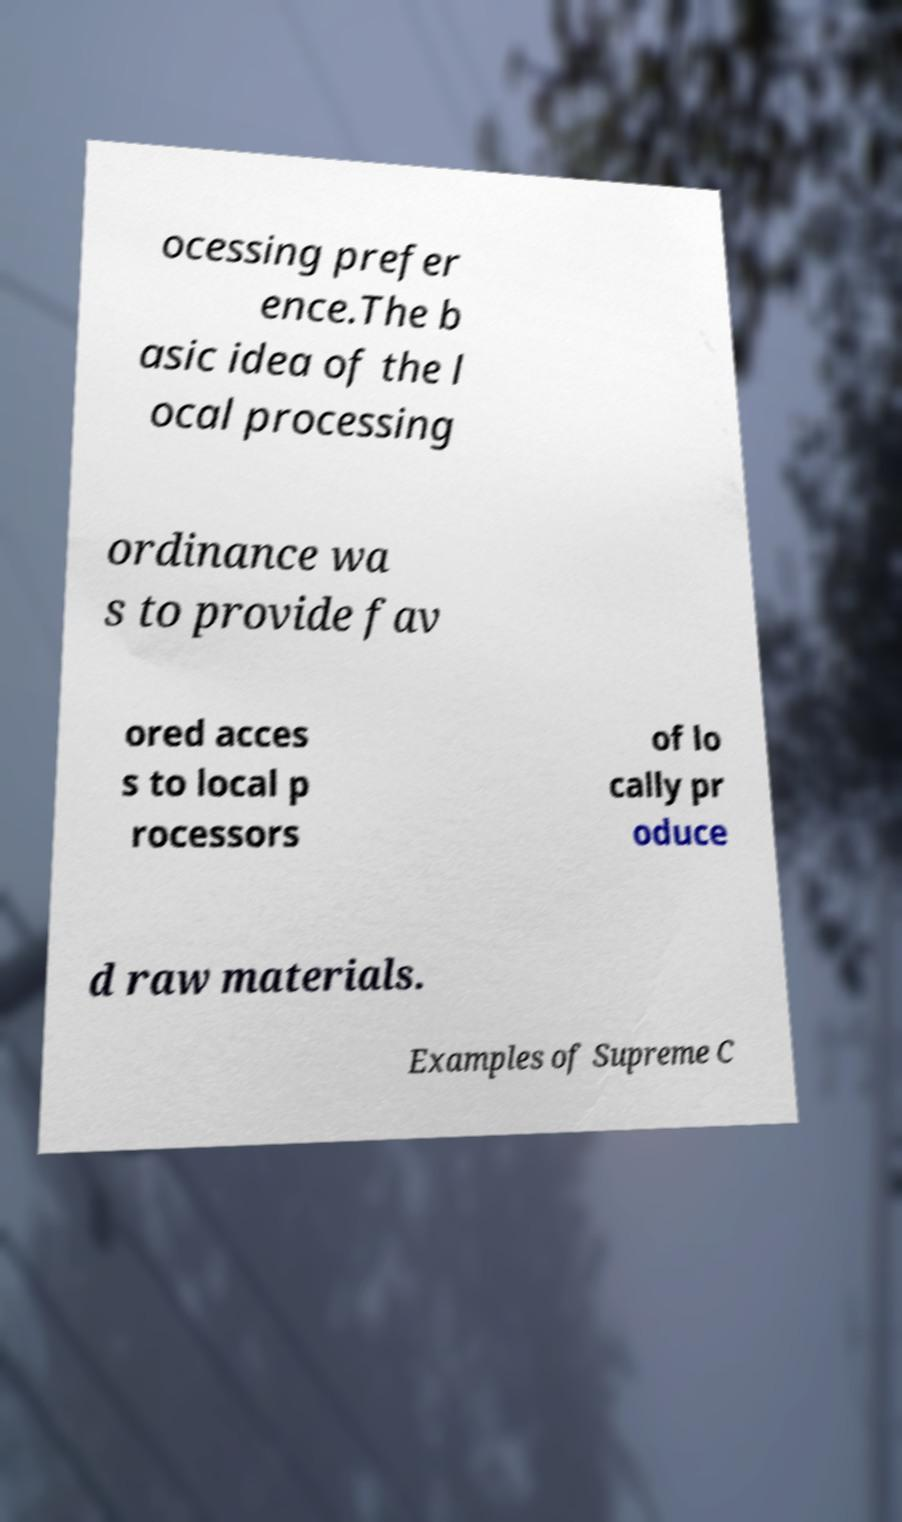I need the written content from this picture converted into text. Can you do that? ocessing prefer ence.The b asic idea of the l ocal processing ordinance wa s to provide fav ored acces s to local p rocessors of lo cally pr oduce d raw materials. Examples of Supreme C 